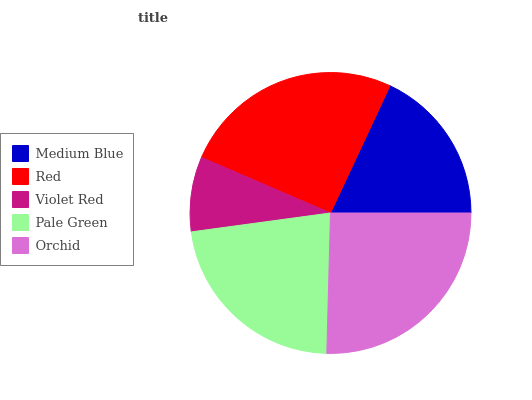Is Violet Red the minimum?
Answer yes or no. Yes. Is Red the maximum?
Answer yes or no. Yes. Is Red the minimum?
Answer yes or no. No. Is Violet Red the maximum?
Answer yes or no. No. Is Red greater than Violet Red?
Answer yes or no. Yes. Is Violet Red less than Red?
Answer yes or no. Yes. Is Violet Red greater than Red?
Answer yes or no. No. Is Red less than Violet Red?
Answer yes or no. No. Is Pale Green the high median?
Answer yes or no. Yes. Is Pale Green the low median?
Answer yes or no. Yes. Is Violet Red the high median?
Answer yes or no. No. Is Red the low median?
Answer yes or no. No. 